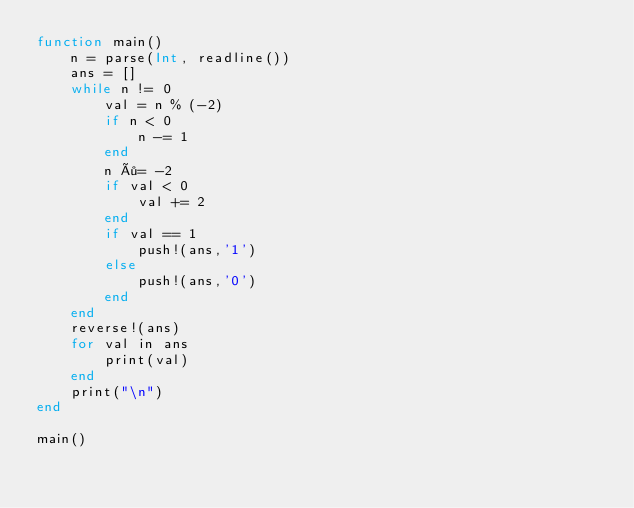<code> <loc_0><loc_0><loc_500><loc_500><_Julia_>function main()
    n = parse(Int, readline())
    ans = []
    while n != 0
        val = n % (-2)
        if n < 0
            n -= 1
        end
        n ÷= -2
        if val < 0
            val += 2
        end
        if val == 1
            push!(ans,'1')
        else
            push!(ans,'0')
        end
    end
    reverse!(ans)
    for val in ans
        print(val)
    end
    print("\n")
end

main()
</code> 